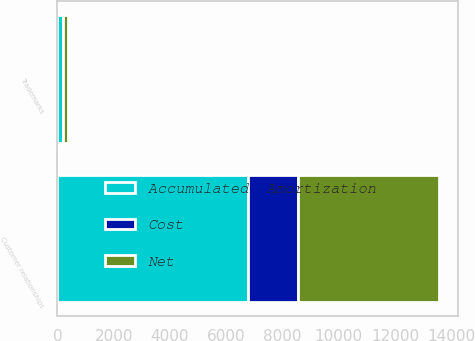Convert chart to OTSL. <chart><loc_0><loc_0><loc_500><loc_500><stacked_bar_chart><ecel><fcel>Customer relationships<fcel>Trademarks<nl><fcel>Accumulated  Amortization<fcel>6782<fcel>181<nl><fcel>Cost<fcel>1782<fcel>22<nl><fcel>Net<fcel>5000<fcel>159<nl></chart> 